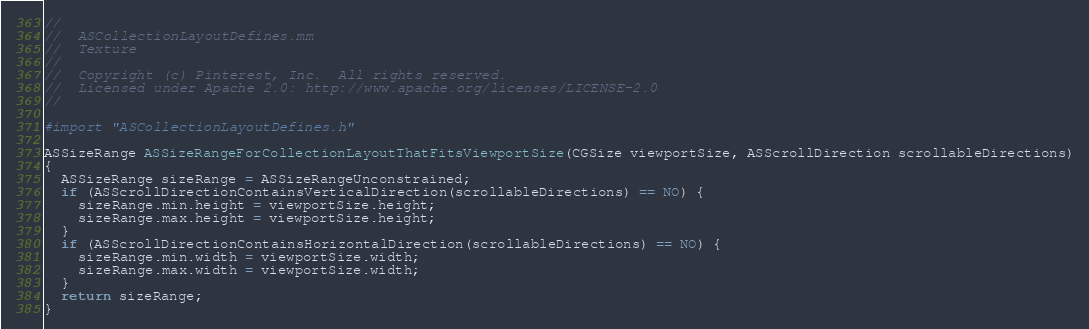Convert code to text. <code><loc_0><loc_0><loc_500><loc_500><_ObjectiveC_>//
//  ASCollectionLayoutDefines.mm
//  Texture
//
//  Copyright (c) Pinterest, Inc.  All rights reserved.
//  Licensed under Apache 2.0: http://www.apache.org/licenses/LICENSE-2.0
//

#import "ASCollectionLayoutDefines.h"

ASSizeRange ASSizeRangeForCollectionLayoutThatFitsViewportSize(CGSize viewportSize, ASScrollDirection scrollableDirections)
{
  ASSizeRange sizeRange = ASSizeRangeUnconstrained;
  if (ASScrollDirectionContainsVerticalDirection(scrollableDirections) == NO) {
    sizeRange.min.height = viewportSize.height;
    sizeRange.max.height = viewportSize.height;
  }
  if (ASScrollDirectionContainsHorizontalDirection(scrollableDirections) == NO) {
    sizeRange.min.width = viewportSize.width;
    sizeRange.max.width = viewportSize.width;
  }
  return sizeRange;
}
</code> 